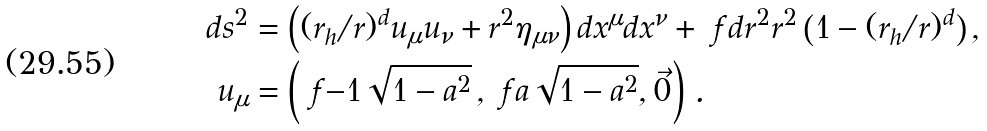<formula> <loc_0><loc_0><loc_500><loc_500>d s ^ { 2 } & = \left ( ( r _ { h } / r ) ^ { d } u _ { \mu } u _ { \nu } + r ^ { 2 } \eta _ { \mu \nu } \right ) d x ^ { \mu } d x ^ { \nu } + \ f { d r ^ { 2 } } { r ^ { 2 } \left ( 1 - ( r _ { h } / r ) ^ { d } \right ) } \, , \\ u _ { \mu } & = \left ( \ f { - 1 } { \sqrt { 1 - a ^ { 2 } } } \, , \ f { a } { \sqrt { 1 - a ^ { 2 } } } , \vec { 0 } \right ) \, .</formula> 